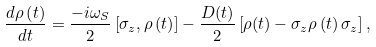<formula> <loc_0><loc_0><loc_500><loc_500>\frac { d \rho \left ( t \right ) } { d t } = \frac { - i \omega _ { S } } { 2 } \left [ \sigma _ { z } , \rho \left ( t \right ) \right ] - \frac { D ( t ) } { 2 } \left [ \rho ( t ) - \sigma _ { z } \rho \left ( t \right ) \sigma _ { z } \right ] ,</formula> 